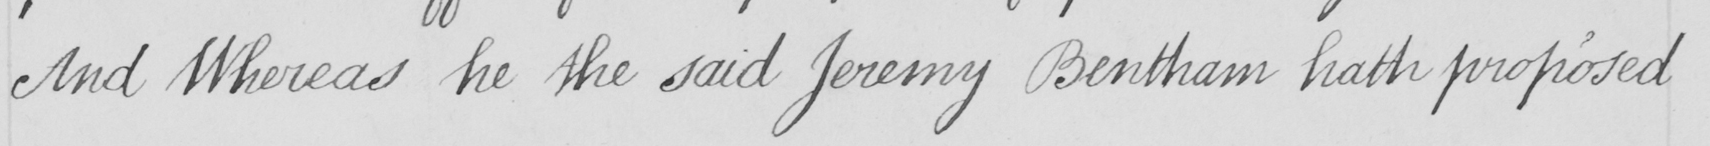What text is written in this handwritten line? And Whereas he the said Jeremy Bentham hath proposed 